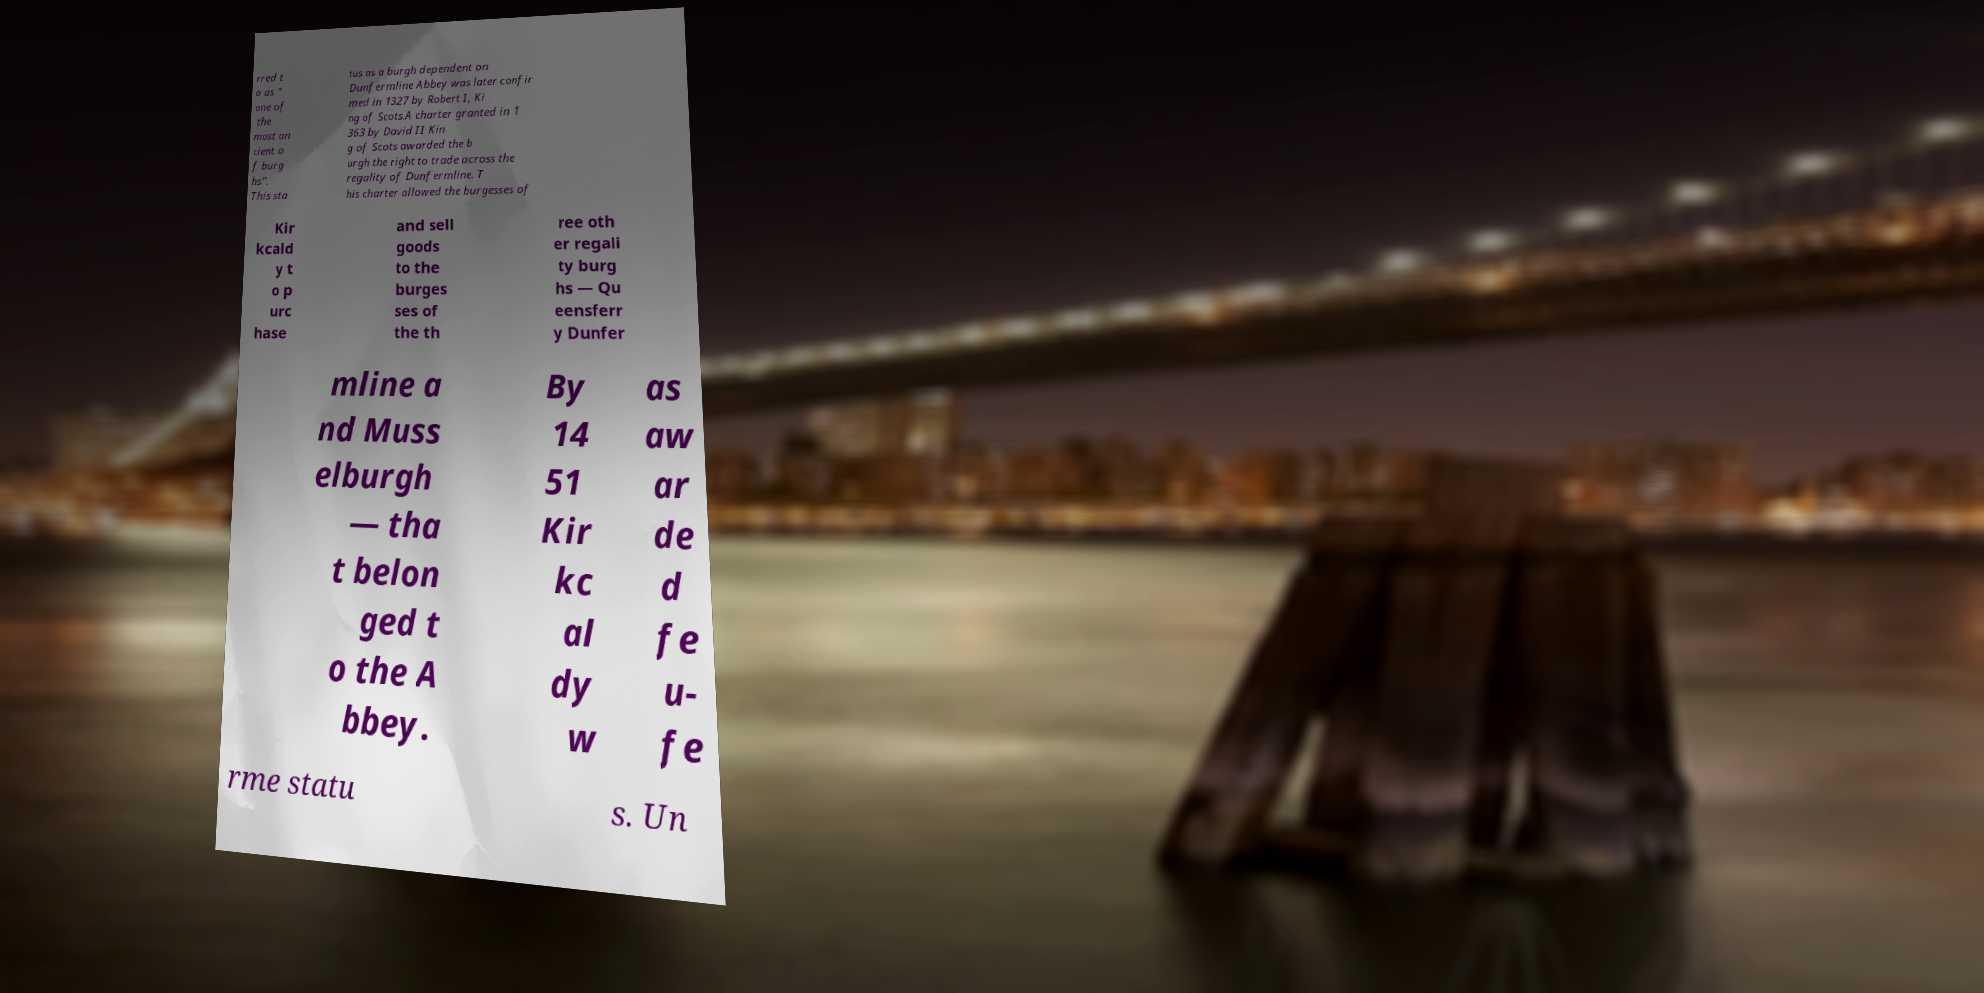Could you assist in decoding the text presented in this image and type it out clearly? rred t o as " one of the most an cient o f burg hs". This sta tus as a burgh dependent on Dunfermline Abbey was later confir med in 1327 by Robert I, Ki ng of Scots.A charter granted in 1 363 by David II Kin g of Scots awarded the b urgh the right to trade across the regality of Dunfermline. T his charter allowed the burgesses of Kir kcald y t o p urc hase and sell goods to the burges ses of the th ree oth er regali ty burg hs — Qu eensferr y Dunfer mline a nd Muss elburgh — tha t belon ged t o the A bbey. By 14 51 Kir kc al dy w as aw ar de d fe u- fe rme statu s. Un 